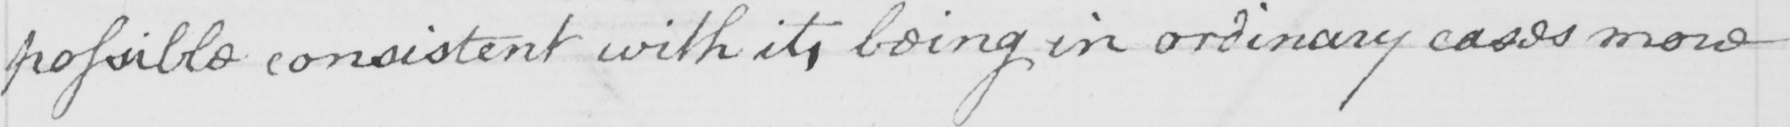What does this handwritten line say? possible consistent with it , being in ordinary cases more 